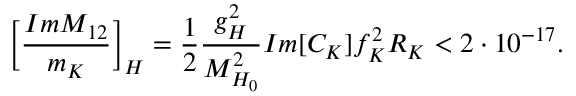<formula> <loc_0><loc_0><loc_500><loc_500>\left [ \frac { I m { M } _ { 1 2 } } { m _ { K } } \right ] _ { H } = \frac { 1 } { 2 } \frac { g _ { H } ^ { 2 } } { M _ { H _ { 0 } } ^ { 2 } } I m [ C _ { K } ] f _ { K } ^ { 2 } R _ { K } < 2 \cdot 1 0 ^ { - 1 7 } .</formula> 